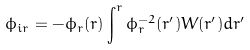<formula> <loc_0><loc_0><loc_500><loc_500>\phi _ { i r } = - \phi _ { r } ( r ) \int ^ { r } \phi _ { r } ^ { - 2 } ( r ^ { \prime } ) W ( r ^ { \prime } ) d r ^ { \prime }</formula> 